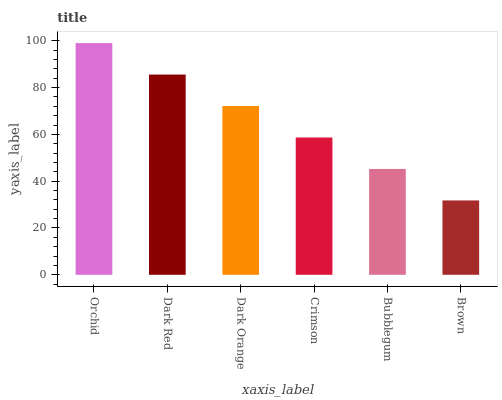Is Dark Red the minimum?
Answer yes or no. No. Is Dark Red the maximum?
Answer yes or no. No. Is Orchid greater than Dark Red?
Answer yes or no. Yes. Is Dark Red less than Orchid?
Answer yes or no. Yes. Is Dark Red greater than Orchid?
Answer yes or no. No. Is Orchid less than Dark Red?
Answer yes or no. No. Is Dark Orange the high median?
Answer yes or no. Yes. Is Crimson the low median?
Answer yes or no. Yes. Is Crimson the high median?
Answer yes or no. No. Is Dark Red the low median?
Answer yes or no. No. 